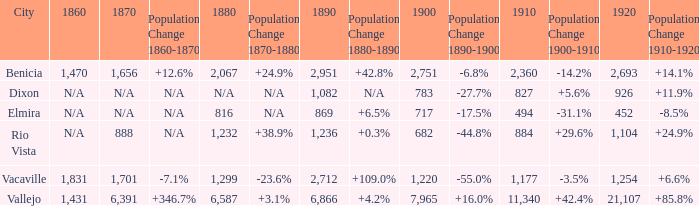What is the 1880 figure when 1860 is N/A and 1910 is 494? 816.0. 